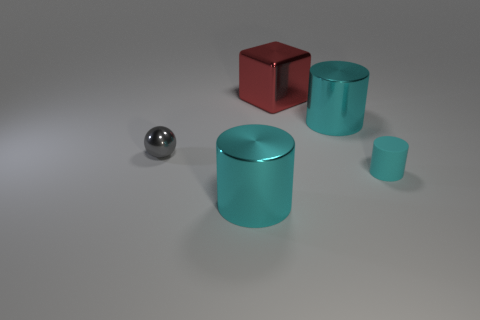Subtract all cyan cylinders. How many were subtracted if there are1cyan cylinders left? 2 Add 4 small red spheres. How many objects exist? 9 Subtract all cubes. How many objects are left? 4 Subtract 1 gray spheres. How many objects are left? 4 Subtract all yellow rubber objects. Subtract all big red shiny things. How many objects are left? 4 Add 1 red objects. How many red objects are left? 2 Add 3 metallic blocks. How many metallic blocks exist? 4 